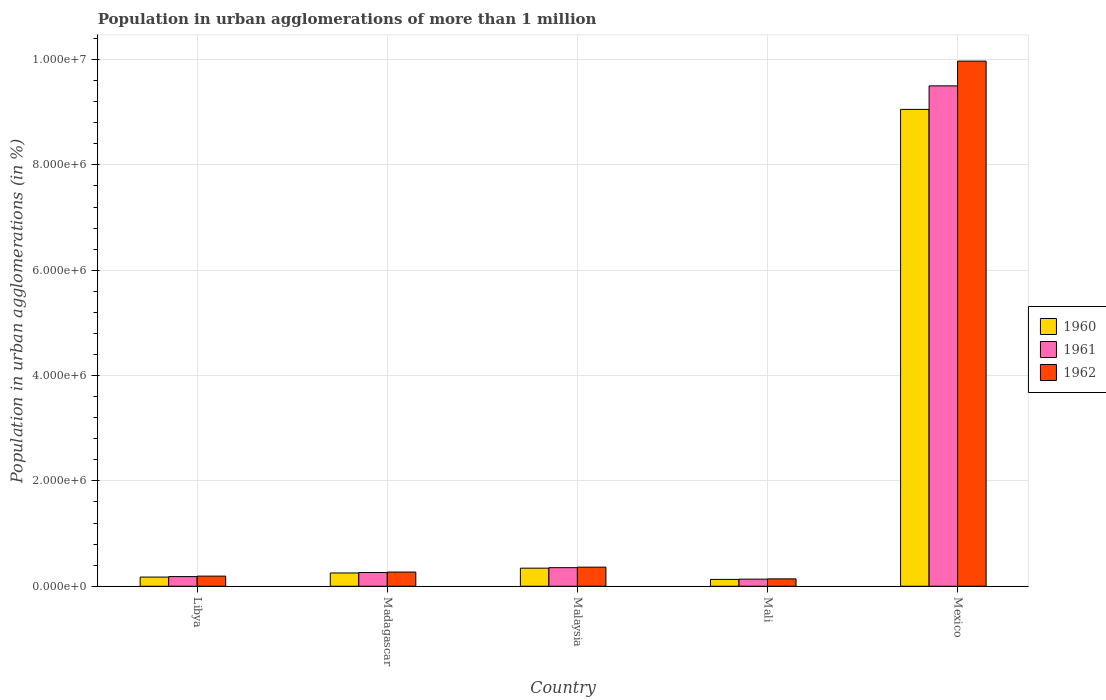How many different coloured bars are there?
Give a very brief answer. 3. How many groups of bars are there?
Keep it short and to the point. 5. Are the number of bars per tick equal to the number of legend labels?
Your answer should be very brief. Yes. How many bars are there on the 2nd tick from the right?
Offer a very short reply. 3. What is the label of the 4th group of bars from the left?
Offer a terse response. Mali. What is the population in urban agglomerations in 1962 in Libya?
Ensure brevity in your answer.  1.92e+05. Across all countries, what is the maximum population in urban agglomerations in 1960?
Give a very brief answer. 9.05e+06. Across all countries, what is the minimum population in urban agglomerations in 1962?
Offer a very short reply. 1.40e+05. In which country was the population in urban agglomerations in 1962 maximum?
Your response must be concise. Mexico. In which country was the population in urban agglomerations in 1961 minimum?
Ensure brevity in your answer.  Mali. What is the total population in urban agglomerations in 1961 in the graph?
Your response must be concise. 1.04e+07. What is the difference between the population in urban agglomerations in 1962 in Libya and that in Madagascar?
Keep it short and to the point. -7.71e+04. What is the difference between the population in urban agglomerations in 1960 in Mali and the population in urban agglomerations in 1962 in Libya?
Ensure brevity in your answer.  -6.24e+04. What is the average population in urban agglomerations in 1962 per country?
Provide a short and direct response. 2.19e+06. What is the difference between the population in urban agglomerations of/in 1960 and population in urban agglomerations of/in 1961 in Madagascar?
Ensure brevity in your answer.  -8560. What is the ratio of the population in urban agglomerations in 1962 in Libya to that in Mali?
Offer a very short reply. 1.37. Is the population in urban agglomerations in 1961 in Libya less than that in Mexico?
Keep it short and to the point. Yes. Is the difference between the population in urban agglomerations in 1960 in Madagascar and Mali greater than the difference between the population in urban agglomerations in 1961 in Madagascar and Mali?
Keep it short and to the point. No. What is the difference between the highest and the second highest population in urban agglomerations in 1961?
Provide a short and direct response. -9.24e+04. What is the difference between the highest and the lowest population in urban agglomerations in 1960?
Provide a succinct answer. 8.92e+06. What does the 2nd bar from the right in Madagascar represents?
Make the answer very short. 1961. How many bars are there?
Your answer should be very brief. 15. Are the values on the major ticks of Y-axis written in scientific E-notation?
Offer a very short reply. Yes. Does the graph contain grids?
Give a very brief answer. Yes. Where does the legend appear in the graph?
Offer a terse response. Center right. What is the title of the graph?
Ensure brevity in your answer.  Population in urban agglomerations of more than 1 million. Does "2010" appear as one of the legend labels in the graph?
Your answer should be compact. No. What is the label or title of the X-axis?
Provide a succinct answer. Country. What is the label or title of the Y-axis?
Your answer should be compact. Population in urban agglomerations (in %). What is the Population in urban agglomerations (in %) in 1960 in Libya?
Give a very brief answer. 1.74e+05. What is the Population in urban agglomerations (in %) of 1961 in Libya?
Make the answer very short. 1.83e+05. What is the Population in urban agglomerations (in %) in 1962 in Libya?
Make the answer very short. 1.92e+05. What is the Population in urban agglomerations (in %) of 1960 in Madagascar?
Your answer should be very brief. 2.52e+05. What is the Population in urban agglomerations (in %) of 1961 in Madagascar?
Offer a terse response. 2.61e+05. What is the Population in urban agglomerations (in %) in 1962 in Madagascar?
Give a very brief answer. 2.70e+05. What is the Population in urban agglomerations (in %) in 1960 in Malaysia?
Provide a succinct answer. 3.44e+05. What is the Population in urban agglomerations (in %) of 1961 in Malaysia?
Keep it short and to the point. 3.53e+05. What is the Population in urban agglomerations (in %) of 1962 in Malaysia?
Keep it short and to the point. 3.63e+05. What is the Population in urban agglomerations (in %) in 1960 in Mali?
Keep it short and to the point. 1.30e+05. What is the Population in urban agglomerations (in %) of 1961 in Mali?
Ensure brevity in your answer.  1.35e+05. What is the Population in urban agglomerations (in %) in 1962 in Mali?
Give a very brief answer. 1.40e+05. What is the Population in urban agglomerations (in %) of 1960 in Mexico?
Offer a terse response. 9.05e+06. What is the Population in urban agglomerations (in %) in 1961 in Mexico?
Provide a succinct answer. 9.50e+06. What is the Population in urban agglomerations (in %) of 1962 in Mexico?
Provide a succinct answer. 9.97e+06. Across all countries, what is the maximum Population in urban agglomerations (in %) of 1960?
Provide a short and direct response. 9.05e+06. Across all countries, what is the maximum Population in urban agglomerations (in %) of 1961?
Your answer should be very brief. 9.50e+06. Across all countries, what is the maximum Population in urban agglomerations (in %) in 1962?
Ensure brevity in your answer.  9.97e+06. Across all countries, what is the minimum Population in urban agglomerations (in %) of 1960?
Your response must be concise. 1.30e+05. Across all countries, what is the minimum Population in urban agglomerations (in %) of 1961?
Make the answer very short. 1.35e+05. Across all countries, what is the minimum Population in urban agglomerations (in %) in 1962?
Provide a short and direct response. 1.40e+05. What is the total Population in urban agglomerations (in %) in 1960 in the graph?
Offer a very short reply. 9.95e+06. What is the total Population in urban agglomerations (in %) of 1961 in the graph?
Offer a very short reply. 1.04e+07. What is the total Population in urban agglomerations (in %) of 1962 in the graph?
Keep it short and to the point. 1.09e+07. What is the difference between the Population in urban agglomerations (in %) in 1960 in Libya and that in Madagascar?
Make the answer very short. -7.79e+04. What is the difference between the Population in urban agglomerations (in %) of 1961 in Libya and that in Madagascar?
Your answer should be very brief. -7.75e+04. What is the difference between the Population in urban agglomerations (in %) in 1962 in Libya and that in Madagascar?
Keep it short and to the point. -7.71e+04. What is the difference between the Population in urban agglomerations (in %) in 1960 in Libya and that in Malaysia?
Your answer should be compact. -1.69e+05. What is the difference between the Population in urban agglomerations (in %) of 1961 in Libya and that in Malaysia?
Offer a very short reply. -1.70e+05. What is the difference between the Population in urban agglomerations (in %) in 1962 in Libya and that in Malaysia?
Offer a very short reply. -1.70e+05. What is the difference between the Population in urban agglomerations (in %) of 1960 in Libya and that in Mali?
Your response must be concise. 4.42e+04. What is the difference between the Population in urban agglomerations (in %) in 1961 in Libya and that in Mali?
Your answer should be very brief. 4.83e+04. What is the difference between the Population in urban agglomerations (in %) of 1962 in Libya and that in Mali?
Make the answer very short. 5.22e+04. What is the difference between the Population in urban agglomerations (in %) in 1960 in Libya and that in Mexico?
Give a very brief answer. -8.88e+06. What is the difference between the Population in urban agglomerations (in %) of 1961 in Libya and that in Mexico?
Offer a very short reply. -9.32e+06. What is the difference between the Population in urban agglomerations (in %) in 1962 in Libya and that in Mexico?
Offer a terse response. -9.78e+06. What is the difference between the Population in urban agglomerations (in %) of 1960 in Madagascar and that in Malaysia?
Offer a very short reply. -9.14e+04. What is the difference between the Population in urban agglomerations (in %) in 1961 in Madagascar and that in Malaysia?
Ensure brevity in your answer.  -9.24e+04. What is the difference between the Population in urban agglomerations (in %) of 1962 in Madagascar and that in Malaysia?
Give a very brief answer. -9.32e+04. What is the difference between the Population in urban agglomerations (in %) in 1960 in Madagascar and that in Mali?
Offer a very short reply. 1.22e+05. What is the difference between the Population in urban agglomerations (in %) of 1961 in Madagascar and that in Mali?
Your response must be concise. 1.26e+05. What is the difference between the Population in urban agglomerations (in %) in 1962 in Madagascar and that in Mali?
Your answer should be very brief. 1.29e+05. What is the difference between the Population in urban agglomerations (in %) of 1960 in Madagascar and that in Mexico?
Keep it short and to the point. -8.80e+06. What is the difference between the Population in urban agglomerations (in %) in 1961 in Madagascar and that in Mexico?
Your answer should be very brief. -9.24e+06. What is the difference between the Population in urban agglomerations (in %) in 1962 in Madagascar and that in Mexico?
Provide a short and direct response. -9.70e+06. What is the difference between the Population in urban agglomerations (in %) of 1960 in Malaysia and that in Mali?
Keep it short and to the point. 2.14e+05. What is the difference between the Population in urban agglomerations (in %) in 1961 in Malaysia and that in Mali?
Give a very brief answer. 2.18e+05. What is the difference between the Population in urban agglomerations (in %) of 1962 in Malaysia and that in Mali?
Your answer should be compact. 2.23e+05. What is the difference between the Population in urban agglomerations (in %) of 1960 in Malaysia and that in Mexico?
Make the answer very short. -8.71e+06. What is the difference between the Population in urban agglomerations (in %) in 1961 in Malaysia and that in Mexico?
Ensure brevity in your answer.  -9.15e+06. What is the difference between the Population in urban agglomerations (in %) in 1962 in Malaysia and that in Mexico?
Give a very brief answer. -9.61e+06. What is the difference between the Population in urban agglomerations (in %) in 1960 in Mali and that in Mexico?
Offer a terse response. -8.92e+06. What is the difference between the Population in urban agglomerations (in %) of 1961 in Mali and that in Mexico?
Give a very brief answer. -9.37e+06. What is the difference between the Population in urban agglomerations (in %) in 1962 in Mali and that in Mexico?
Make the answer very short. -9.83e+06. What is the difference between the Population in urban agglomerations (in %) in 1960 in Libya and the Population in urban agglomerations (in %) in 1961 in Madagascar?
Keep it short and to the point. -8.64e+04. What is the difference between the Population in urban agglomerations (in %) in 1960 in Libya and the Population in urban agglomerations (in %) in 1962 in Madagascar?
Your response must be concise. -9.53e+04. What is the difference between the Population in urban agglomerations (in %) of 1961 in Libya and the Population in urban agglomerations (in %) of 1962 in Madagascar?
Make the answer very short. -8.64e+04. What is the difference between the Population in urban agglomerations (in %) in 1960 in Libya and the Population in urban agglomerations (in %) in 1961 in Malaysia?
Ensure brevity in your answer.  -1.79e+05. What is the difference between the Population in urban agglomerations (in %) of 1960 in Libya and the Population in urban agglomerations (in %) of 1962 in Malaysia?
Your answer should be compact. -1.89e+05. What is the difference between the Population in urban agglomerations (in %) of 1961 in Libya and the Population in urban agglomerations (in %) of 1962 in Malaysia?
Your answer should be compact. -1.80e+05. What is the difference between the Population in urban agglomerations (in %) in 1960 in Libya and the Population in urban agglomerations (in %) in 1961 in Mali?
Offer a very short reply. 3.94e+04. What is the difference between the Population in urban agglomerations (in %) in 1960 in Libya and the Population in urban agglomerations (in %) in 1962 in Mali?
Provide a short and direct response. 3.40e+04. What is the difference between the Population in urban agglomerations (in %) of 1961 in Libya and the Population in urban agglomerations (in %) of 1962 in Mali?
Give a very brief answer. 4.28e+04. What is the difference between the Population in urban agglomerations (in %) in 1960 in Libya and the Population in urban agglomerations (in %) in 1961 in Mexico?
Provide a succinct answer. -9.33e+06. What is the difference between the Population in urban agglomerations (in %) of 1960 in Libya and the Population in urban agglomerations (in %) of 1962 in Mexico?
Your answer should be very brief. -9.80e+06. What is the difference between the Population in urban agglomerations (in %) of 1961 in Libya and the Population in urban agglomerations (in %) of 1962 in Mexico?
Your response must be concise. -9.79e+06. What is the difference between the Population in urban agglomerations (in %) of 1960 in Madagascar and the Population in urban agglomerations (in %) of 1961 in Malaysia?
Offer a very short reply. -1.01e+05. What is the difference between the Population in urban agglomerations (in %) in 1960 in Madagascar and the Population in urban agglomerations (in %) in 1962 in Malaysia?
Provide a short and direct response. -1.11e+05. What is the difference between the Population in urban agglomerations (in %) of 1961 in Madagascar and the Population in urban agglomerations (in %) of 1962 in Malaysia?
Offer a very short reply. -1.02e+05. What is the difference between the Population in urban agglomerations (in %) of 1960 in Madagascar and the Population in urban agglomerations (in %) of 1961 in Mali?
Keep it short and to the point. 1.17e+05. What is the difference between the Population in urban agglomerations (in %) of 1960 in Madagascar and the Population in urban agglomerations (in %) of 1962 in Mali?
Provide a short and direct response. 1.12e+05. What is the difference between the Population in urban agglomerations (in %) in 1961 in Madagascar and the Population in urban agglomerations (in %) in 1962 in Mali?
Keep it short and to the point. 1.20e+05. What is the difference between the Population in urban agglomerations (in %) of 1960 in Madagascar and the Population in urban agglomerations (in %) of 1961 in Mexico?
Make the answer very short. -9.25e+06. What is the difference between the Population in urban agglomerations (in %) in 1960 in Madagascar and the Population in urban agglomerations (in %) in 1962 in Mexico?
Make the answer very short. -9.72e+06. What is the difference between the Population in urban agglomerations (in %) of 1961 in Madagascar and the Population in urban agglomerations (in %) of 1962 in Mexico?
Your response must be concise. -9.71e+06. What is the difference between the Population in urban agglomerations (in %) in 1960 in Malaysia and the Population in urban agglomerations (in %) in 1961 in Mali?
Make the answer very short. 2.09e+05. What is the difference between the Population in urban agglomerations (in %) in 1960 in Malaysia and the Population in urban agglomerations (in %) in 1962 in Mali?
Offer a very short reply. 2.03e+05. What is the difference between the Population in urban agglomerations (in %) in 1961 in Malaysia and the Population in urban agglomerations (in %) in 1962 in Mali?
Provide a succinct answer. 2.13e+05. What is the difference between the Population in urban agglomerations (in %) in 1960 in Malaysia and the Population in urban agglomerations (in %) in 1961 in Mexico?
Keep it short and to the point. -9.16e+06. What is the difference between the Population in urban agglomerations (in %) of 1960 in Malaysia and the Population in urban agglomerations (in %) of 1962 in Mexico?
Provide a short and direct response. -9.63e+06. What is the difference between the Population in urban agglomerations (in %) in 1961 in Malaysia and the Population in urban agglomerations (in %) in 1962 in Mexico?
Your response must be concise. -9.62e+06. What is the difference between the Population in urban agglomerations (in %) of 1960 in Mali and the Population in urban agglomerations (in %) of 1961 in Mexico?
Provide a short and direct response. -9.37e+06. What is the difference between the Population in urban agglomerations (in %) in 1960 in Mali and the Population in urban agglomerations (in %) in 1962 in Mexico?
Your response must be concise. -9.84e+06. What is the difference between the Population in urban agglomerations (in %) of 1961 in Mali and the Population in urban agglomerations (in %) of 1962 in Mexico?
Provide a short and direct response. -9.84e+06. What is the average Population in urban agglomerations (in %) in 1960 per country?
Your answer should be very brief. 1.99e+06. What is the average Population in urban agglomerations (in %) in 1961 per country?
Your answer should be very brief. 2.09e+06. What is the average Population in urban agglomerations (in %) in 1962 per country?
Your answer should be very brief. 2.19e+06. What is the difference between the Population in urban agglomerations (in %) of 1960 and Population in urban agglomerations (in %) of 1961 in Libya?
Offer a very short reply. -8884. What is the difference between the Population in urban agglomerations (in %) in 1960 and Population in urban agglomerations (in %) in 1962 in Libya?
Offer a very short reply. -1.82e+04. What is the difference between the Population in urban agglomerations (in %) in 1961 and Population in urban agglomerations (in %) in 1962 in Libya?
Offer a very short reply. -9351. What is the difference between the Population in urban agglomerations (in %) in 1960 and Population in urban agglomerations (in %) in 1961 in Madagascar?
Ensure brevity in your answer.  -8560. What is the difference between the Population in urban agglomerations (in %) of 1960 and Population in urban agglomerations (in %) of 1962 in Madagascar?
Provide a succinct answer. -1.74e+04. What is the difference between the Population in urban agglomerations (in %) in 1961 and Population in urban agglomerations (in %) in 1962 in Madagascar?
Ensure brevity in your answer.  -8864. What is the difference between the Population in urban agglomerations (in %) of 1960 and Population in urban agglomerations (in %) of 1961 in Malaysia?
Your answer should be compact. -9483. What is the difference between the Population in urban agglomerations (in %) in 1960 and Population in urban agglomerations (in %) in 1962 in Malaysia?
Provide a succinct answer. -1.92e+04. What is the difference between the Population in urban agglomerations (in %) of 1961 and Population in urban agglomerations (in %) of 1962 in Malaysia?
Provide a short and direct response. -9758. What is the difference between the Population in urban agglomerations (in %) of 1960 and Population in urban agglomerations (in %) of 1961 in Mali?
Keep it short and to the point. -4767. What is the difference between the Population in urban agglomerations (in %) of 1960 and Population in urban agglomerations (in %) of 1962 in Mali?
Your answer should be very brief. -1.02e+04. What is the difference between the Population in urban agglomerations (in %) of 1961 and Population in urban agglomerations (in %) of 1962 in Mali?
Ensure brevity in your answer.  -5483. What is the difference between the Population in urban agglomerations (in %) of 1960 and Population in urban agglomerations (in %) of 1961 in Mexico?
Offer a terse response. -4.46e+05. What is the difference between the Population in urban agglomerations (in %) in 1960 and Population in urban agglomerations (in %) in 1962 in Mexico?
Your answer should be compact. -9.16e+05. What is the difference between the Population in urban agglomerations (in %) in 1961 and Population in urban agglomerations (in %) in 1962 in Mexico?
Ensure brevity in your answer.  -4.70e+05. What is the ratio of the Population in urban agglomerations (in %) of 1960 in Libya to that in Madagascar?
Your response must be concise. 0.69. What is the ratio of the Population in urban agglomerations (in %) of 1961 in Libya to that in Madagascar?
Offer a very short reply. 0.7. What is the ratio of the Population in urban agglomerations (in %) of 1962 in Libya to that in Madagascar?
Your answer should be compact. 0.71. What is the ratio of the Population in urban agglomerations (in %) of 1960 in Libya to that in Malaysia?
Provide a succinct answer. 0.51. What is the ratio of the Population in urban agglomerations (in %) in 1961 in Libya to that in Malaysia?
Offer a terse response. 0.52. What is the ratio of the Population in urban agglomerations (in %) of 1962 in Libya to that in Malaysia?
Provide a succinct answer. 0.53. What is the ratio of the Population in urban agglomerations (in %) of 1960 in Libya to that in Mali?
Offer a very short reply. 1.34. What is the ratio of the Population in urban agglomerations (in %) of 1961 in Libya to that in Mali?
Make the answer very short. 1.36. What is the ratio of the Population in urban agglomerations (in %) of 1962 in Libya to that in Mali?
Provide a short and direct response. 1.37. What is the ratio of the Population in urban agglomerations (in %) in 1960 in Libya to that in Mexico?
Your answer should be very brief. 0.02. What is the ratio of the Population in urban agglomerations (in %) of 1961 in Libya to that in Mexico?
Provide a short and direct response. 0.02. What is the ratio of the Population in urban agglomerations (in %) in 1962 in Libya to that in Mexico?
Offer a very short reply. 0.02. What is the ratio of the Population in urban agglomerations (in %) in 1960 in Madagascar to that in Malaysia?
Provide a short and direct response. 0.73. What is the ratio of the Population in urban agglomerations (in %) in 1961 in Madagascar to that in Malaysia?
Ensure brevity in your answer.  0.74. What is the ratio of the Population in urban agglomerations (in %) of 1962 in Madagascar to that in Malaysia?
Your response must be concise. 0.74. What is the ratio of the Population in urban agglomerations (in %) of 1960 in Madagascar to that in Mali?
Offer a terse response. 1.94. What is the ratio of the Population in urban agglomerations (in %) in 1961 in Madagascar to that in Mali?
Provide a short and direct response. 1.93. What is the ratio of the Population in urban agglomerations (in %) of 1962 in Madagascar to that in Mali?
Offer a very short reply. 1.92. What is the ratio of the Population in urban agglomerations (in %) of 1960 in Madagascar to that in Mexico?
Your response must be concise. 0.03. What is the ratio of the Population in urban agglomerations (in %) in 1961 in Madagascar to that in Mexico?
Give a very brief answer. 0.03. What is the ratio of the Population in urban agglomerations (in %) in 1962 in Madagascar to that in Mexico?
Make the answer very short. 0.03. What is the ratio of the Population in urban agglomerations (in %) of 1960 in Malaysia to that in Mali?
Offer a terse response. 2.64. What is the ratio of the Population in urban agglomerations (in %) in 1961 in Malaysia to that in Mali?
Keep it short and to the point. 2.62. What is the ratio of the Population in urban agglomerations (in %) of 1962 in Malaysia to that in Mali?
Your response must be concise. 2.59. What is the ratio of the Population in urban agglomerations (in %) in 1960 in Malaysia to that in Mexico?
Offer a very short reply. 0.04. What is the ratio of the Population in urban agglomerations (in %) in 1961 in Malaysia to that in Mexico?
Make the answer very short. 0.04. What is the ratio of the Population in urban agglomerations (in %) of 1962 in Malaysia to that in Mexico?
Your answer should be very brief. 0.04. What is the ratio of the Population in urban agglomerations (in %) of 1960 in Mali to that in Mexico?
Ensure brevity in your answer.  0.01. What is the ratio of the Population in urban agglomerations (in %) of 1961 in Mali to that in Mexico?
Provide a short and direct response. 0.01. What is the ratio of the Population in urban agglomerations (in %) in 1962 in Mali to that in Mexico?
Offer a terse response. 0.01. What is the difference between the highest and the second highest Population in urban agglomerations (in %) in 1960?
Provide a short and direct response. 8.71e+06. What is the difference between the highest and the second highest Population in urban agglomerations (in %) of 1961?
Offer a terse response. 9.15e+06. What is the difference between the highest and the second highest Population in urban agglomerations (in %) of 1962?
Ensure brevity in your answer.  9.61e+06. What is the difference between the highest and the lowest Population in urban agglomerations (in %) in 1960?
Provide a short and direct response. 8.92e+06. What is the difference between the highest and the lowest Population in urban agglomerations (in %) of 1961?
Provide a succinct answer. 9.37e+06. What is the difference between the highest and the lowest Population in urban agglomerations (in %) of 1962?
Offer a very short reply. 9.83e+06. 